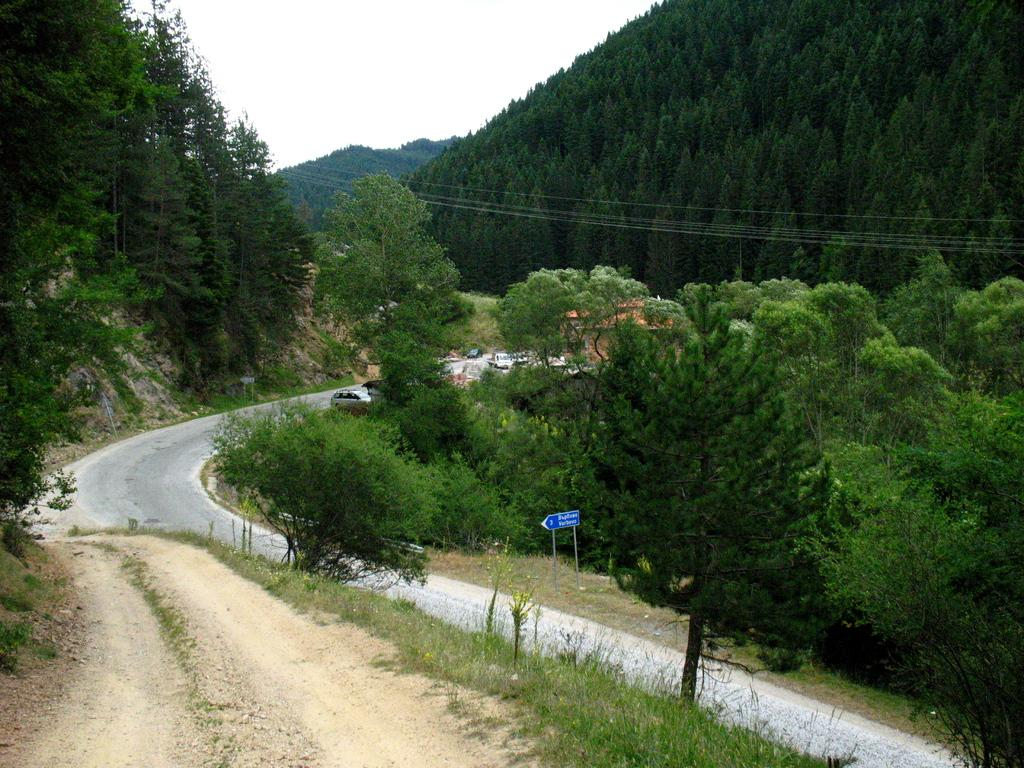What is the main feature of the image? There is a road in the image. What can be seen alongside the road? Trees are present alongside the road. Are there any vehicles visible in the image? Yes, there are vehicles parked beside the road in the distance. What can be seen in the background of the image? There is a mountain visible in the background. How are the trees on the mountain described? The mountain is covered with thick and dense trees. What type of sock is hanging from the tree on the left side of the image? There is no sock present in the image; it only features a road, trees, vehicles, and a mountain. 